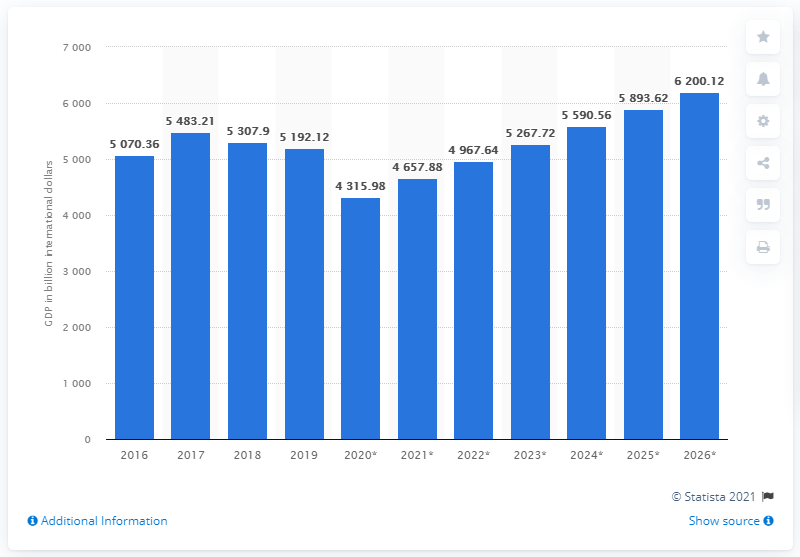Point out several critical features in this image. In 2019, the Gross Domestic Product (GDP) of Latin America and the Caribbean was 5192.12. 